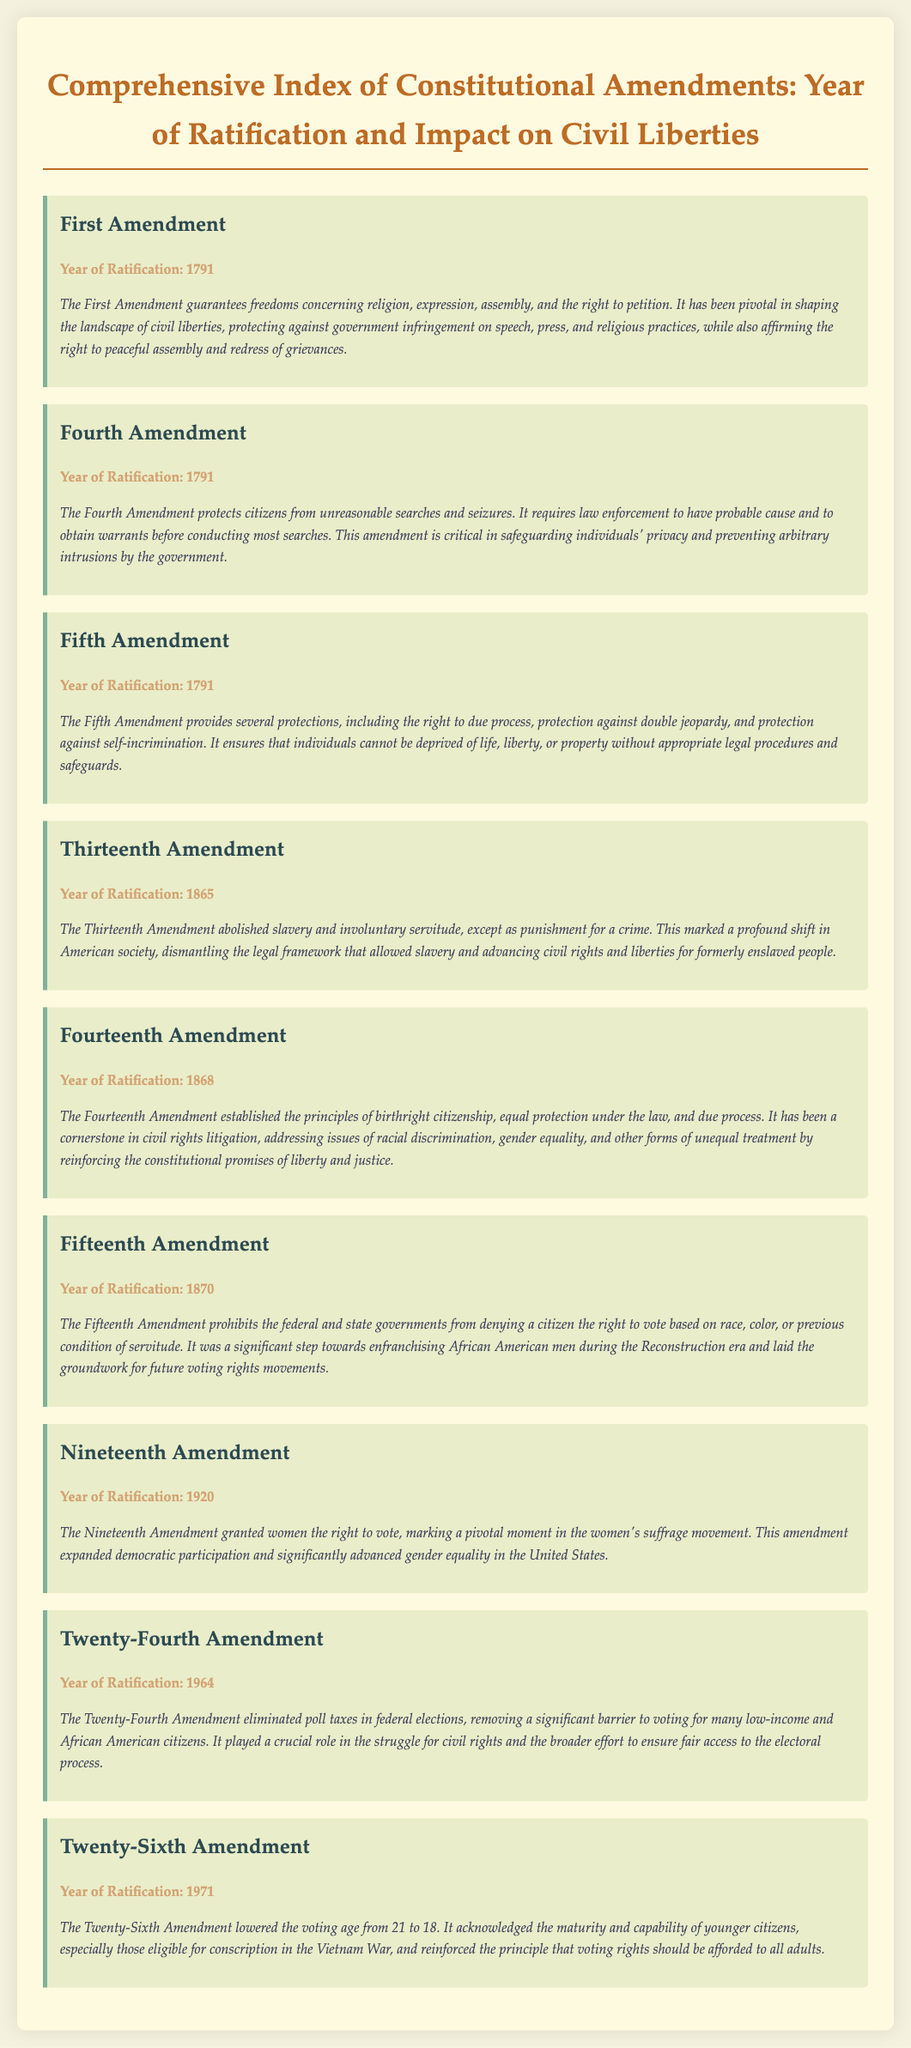What is the year of ratification for the First Amendment? The year of ratification is mentioned directly in the section for the First Amendment.
Answer: 1791 How many amendments are related to voting rights? The document outlines several amendments that discuss voting rights, specifically the Fifteenth, Nineteenth, Twenty-Fourth, and Twenty-Sixth Amendments.
Answer: Four What does the Fourth Amendment protect against? The document describes the Fourth Amendment's protections in its impact section, specifically regarding law enforcement actions.
Answer: Unreasonable searches and seizures What was a major impact of the Thirteenth Amendment? The major impact is noted in the impact description, emphasizing the end of a specific institution.
Answer: Abolished slavery Which amendment provided women the right to vote? The specific amendment that granted women's voting rights is indicated in the relevant section.
Answer: Nineteenth Amendment In what year was the Twenty-Fourth Amendment ratified? The year of ratification is listed clearly for this amendment in the document.
Answer: 1964 Which amendment is considered a cornerstone in civil rights litigation? The document assigns this significance to one of the amendments in its impact section.
Answer: Fourteenth Amendment What is a requirement set by the Fifth Amendment? The document lists several protections that are included in this amendment, one of which satisfies this question.
Answer: Right to due process 